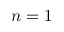Convert formula to latex. <formula><loc_0><loc_0><loc_500><loc_500>n = 1</formula> 